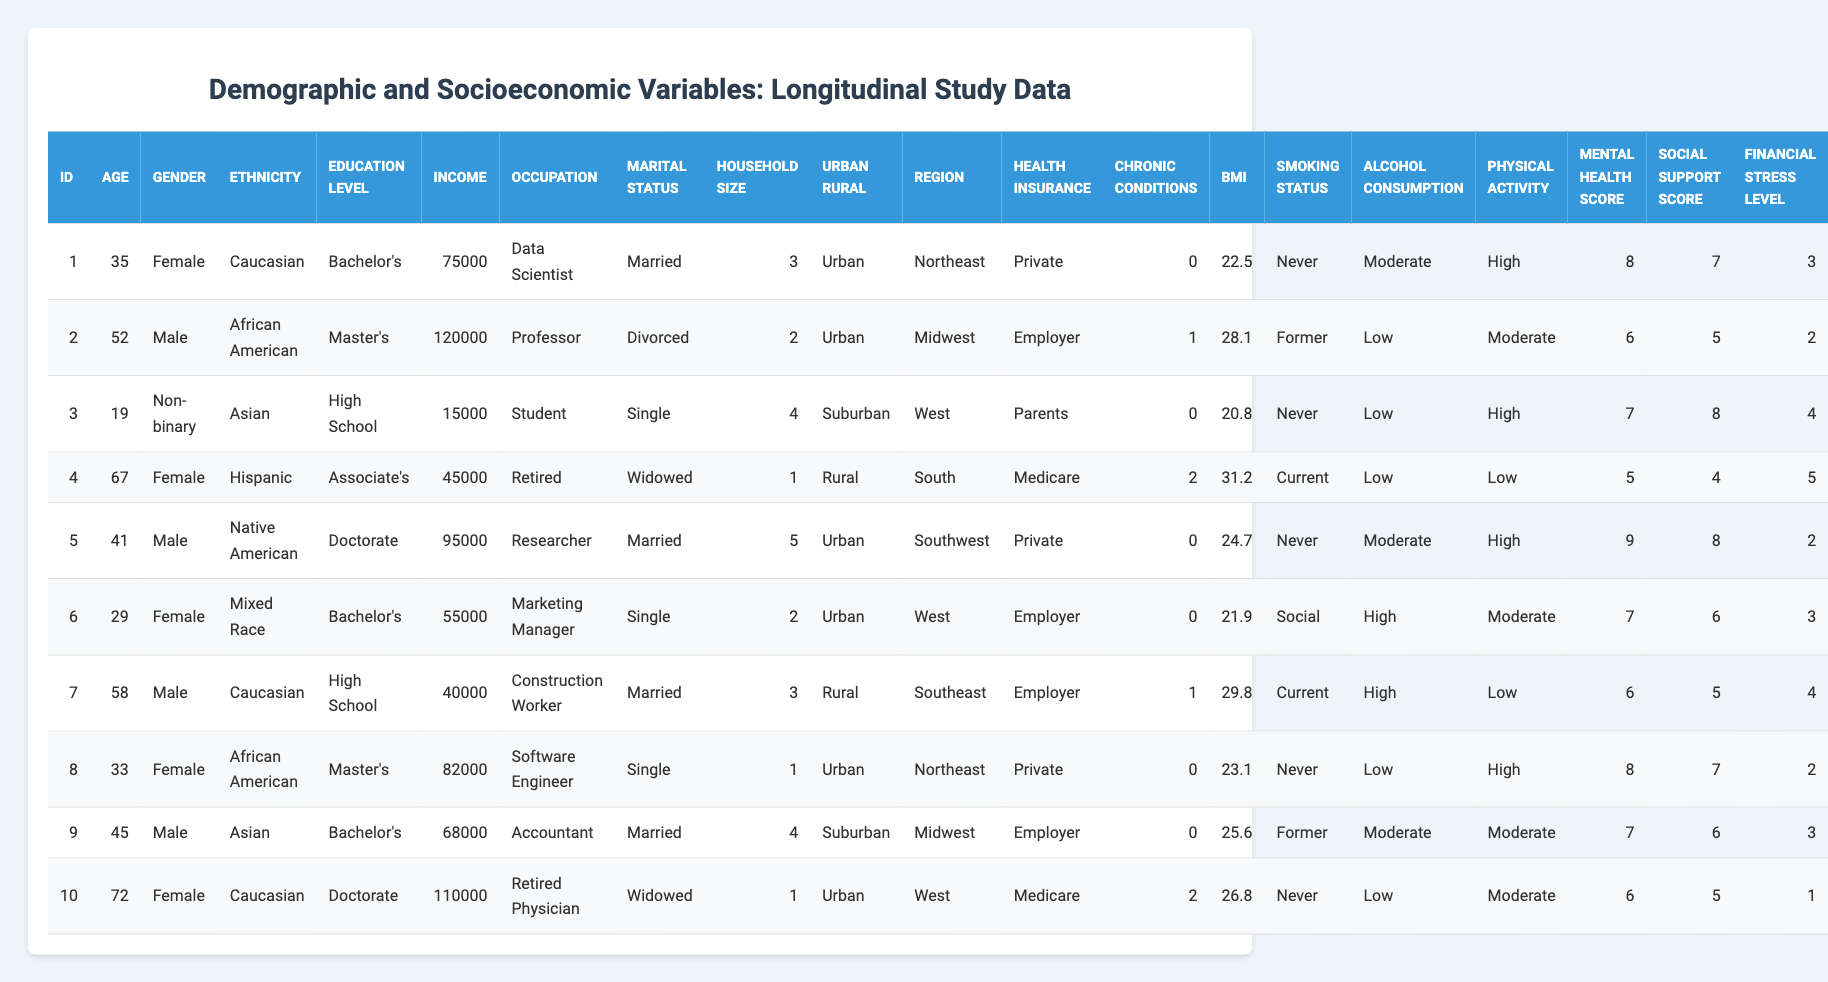What is the highest reported income in the table? Scanning through the income column, the highest value listed is 120000, found in the row for the individual with id 2.
Answer: 120000 What is the average age of the individuals in the dataset? There are 10 individuals in the dataset, and their ages are: 35, 52, 19, 67, 41, 29, 58, 33, 45, and 72. Summing these gives  35 + 52 + 19 + 67 + 41 + 29 + 58 + 33 + 45 + 72 = 411. Then, dividing this sum by the number of individuals (10), yields an average age of 411/10 = 41.1.
Answer: 41.1 How many individuals have a bachelor's degree? I need to count the occurrences of 'Bachelor's' in the education level column. There are 3 individuals with this education level (id 1, 3, and 9).
Answer: 3 Is there anyone who has both Medicare insurance and chronic conditions? Looking at the health insurance and chronic conditions columns, id 4 has Medicare and has 2 chronic conditions. Therefore, there is at least one individual with both traits.
Answer: Yes Who is the youngest individual in the dataset, and what is their occupation? Searching the age column quickly identifies id 3 as the youngest person at 19 years old. Their occupation is 'Student.'
Answer: Student What is the total household size of individuals who are 'Single'? Checking the household size of individuals marked as 'Single' (id 3 and 6), we have 4 (from id 3) + 2 (from id 6), which equals 6.
Answer: 6 How many individuals smoke? By inspecting the smoking status column, individuals id 4, 7, and any current smokers contribute to the count. Therefore, 3 individuals smoke.
Answer: 3 What is the average BMI of married individuals? I first identify the married individuals (id 1, 5, 7, 9), then calculate the average BMI: (22.5 + 24.7 + 29.8 + 25.6) / 4 = 25.4.
Answer: 25.4 Is there any individual with a high financial stress level who does not have health insurance? All individuals have some form of health insurance listed. Checking the financial stress levels against insurance, the answer is no.
Answer: No What is the most common occupation among the listed individuals? By tallying the occupations in the table, 'Married' appears twice (id 1 and 5), while 'Single' also occurs twice (id 3 and 6). The highest count is for 'Data Scientist' at one instance. The conclusion here is that several occupations are equally common.
Answer: Data Scientist, Researcher, Professor, etc 